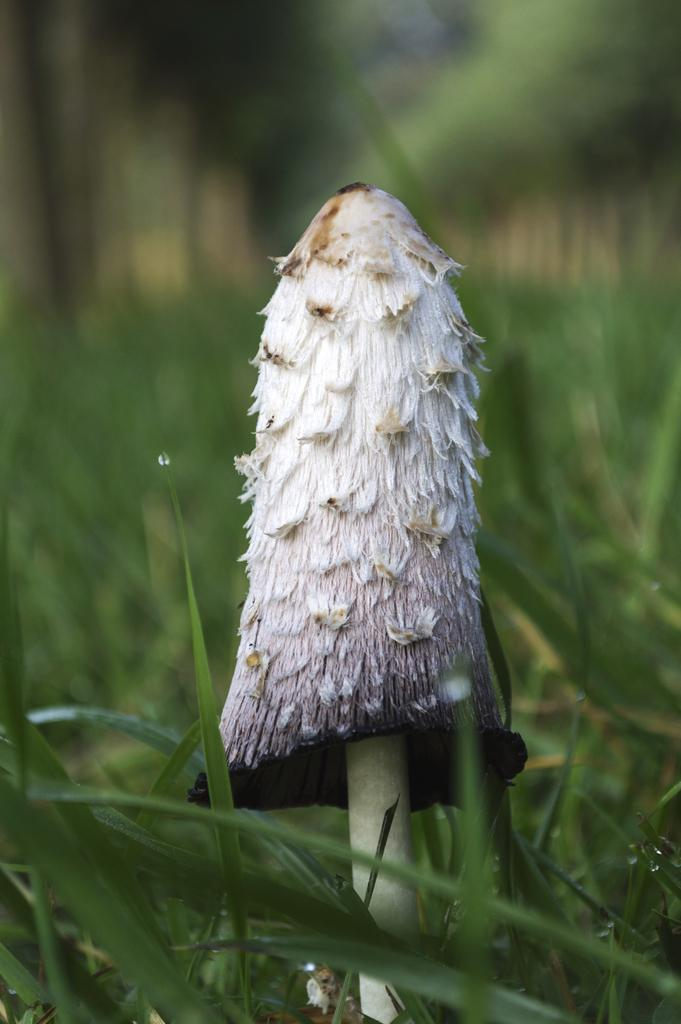What type of fungus can be seen in the image? There is a mushroom in the image. What is the color of the mushroom? The mushroom is white in color. What type of vegetation is present in the image? There is grass in the image. What is the color of the grass? The grass is green in color. Can you see any fairies dancing around the mushroom in the image? There are no fairies present in the image; it only features a mushroom and grass. What type of curtain can be seen hanging from the mushroom in the image? There is no curtain present in the image; it only features a mushroom and grass. 